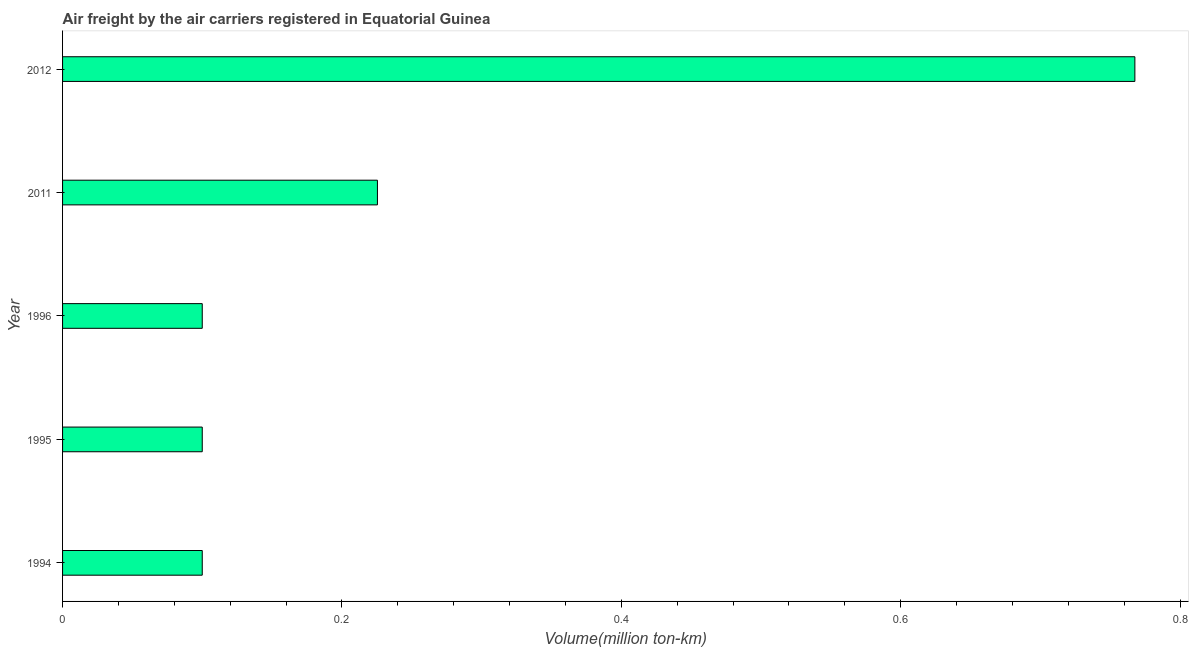Does the graph contain any zero values?
Offer a terse response. No. Does the graph contain grids?
Provide a succinct answer. No. What is the title of the graph?
Offer a terse response. Air freight by the air carriers registered in Equatorial Guinea. What is the label or title of the X-axis?
Your answer should be compact. Volume(million ton-km). What is the air freight in 1996?
Keep it short and to the point. 0.1. Across all years, what is the maximum air freight?
Give a very brief answer. 0.77. Across all years, what is the minimum air freight?
Make the answer very short. 0.1. In which year was the air freight minimum?
Your response must be concise. 1994. What is the sum of the air freight?
Your response must be concise. 1.29. What is the difference between the air freight in 1995 and 2011?
Offer a terse response. -0.12. What is the average air freight per year?
Give a very brief answer. 0.26. What is the median air freight?
Keep it short and to the point. 0.1. Do a majority of the years between 2011 and 1995 (inclusive) have air freight greater than 0.6 million ton-km?
Provide a short and direct response. Yes. What is the ratio of the air freight in 1996 to that in 2011?
Give a very brief answer. 0.44. What is the difference between the highest and the second highest air freight?
Make the answer very short. 0.54. What is the difference between the highest and the lowest air freight?
Offer a terse response. 0.67. In how many years, is the air freight greater than the average air freight taken over all years?
Make the answer very short. 1. Are all the bars in the graph horizontal?
Provide a succinct answer. Yes. How many years are there in the graph?
Provide a short and direct response. 5. What is the difference between two consecutive major ticks on the X-axis?
Ensure brevity in your answer.  0.2. What is the Volume(million ton-km) in 1994?
Your response must be concise. 0.1. What is the Volume(million ton-km) of 1995?
Provide a short and direct response. 0.1. What is the Volume(million ton-km) in 1996?
Offer a terse response. 0.1. What is the Volume(million ton-km) of 2011?
Provide a succinct answer. 0.23. What is the Volume(million ton-km) in 2012?
Keep it short and to the point. 0.77. What is the difference between the Volume(million ton-km) in 1994 and 1995?
Your answer should be very brief. 0. What is the difference between the Volume(million ton-km) in 1994 and 2011?
Make the answer very short. -0.13. What is the difference between the Volume(million ton-km) in 1994 and 2012?
Offer a terse response. -0.67. What is the difference between the Volume(million ton-km) in 1995 and 1996?
Your response must be concise. 0. What is the difference between the Volume(million ton-km) in 1995 and 2011?
Offer a terse response. -0.13. What is the difference between the Volume(million ton-km) in 1995 and 2012?
Provide a succinct answer. -0.67. What is the difference between the Volume(million ton-km) in 1996 and 2011?
Your answer should be compact. -0.13. What is the difference between the Volume(million ton-km) in 1996 and 2012?
Make the answer very short. -0.67. What is the difference between the Volume(million ton-km) in 2011 and 2012?
Your answer should be compact. -0.54. What is the ratio of the Volume(million ton-km) in 1994 to that in 1995?
Provide a succinct answer. 1. What is the ratio of the Volume(million ton-km) in 1994 to that in 2011?
Your answer should be compact. 0.44. What is the ratio of the Volume(million ton-km) in 1994 to that in 2012?
Provide a short and direct response. 0.13. What is the ratio of the Volume(million ton-km) in 1995 to that in 2011?
Offer a terse response. 0.44. What is the ratio of the Volume(million ton-km) in 1995 to that in 2012?
Ensure brevity in your answer.  0.13. What is the ratio of the Volume(million ton-km) in 1996 to that in 2011?
Ensure brevity in your answer.  0.44. What is the ratio of the Volume(million ton-km) in 1996 to that in 2012?
Give a very brief answer. 0.13. What is the ratio of the Volume(million ton-km) in 2011 to that in 2012?
Give a very brief answer. 0.29. 